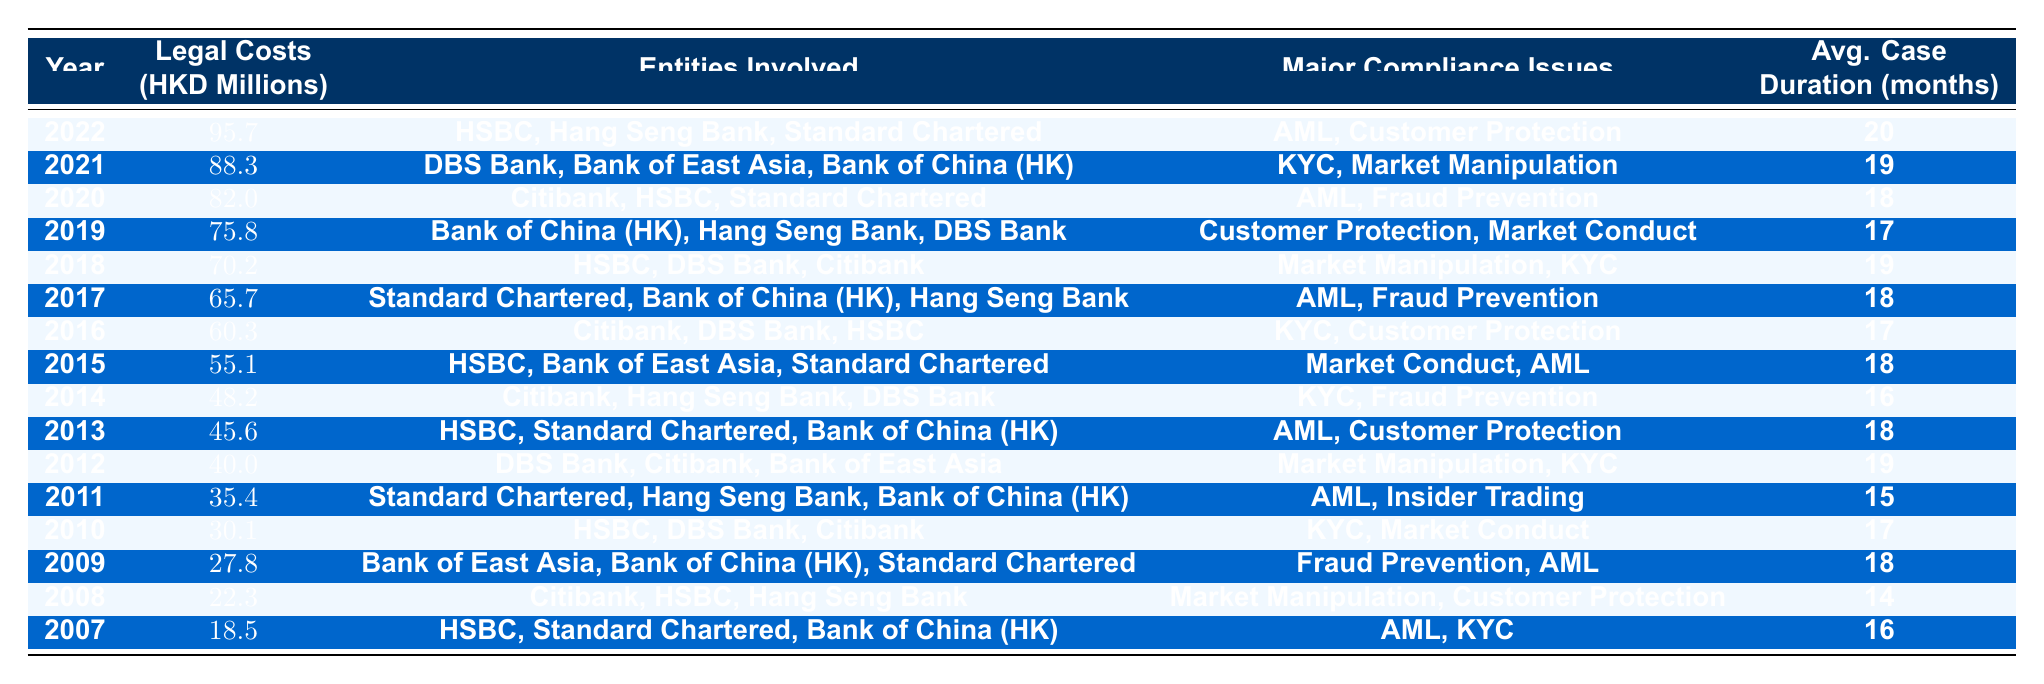What were the legal costs in 2010? The table indicates that the legal costs for the year 2010 were 30.1 million HKD.
Answer: 30.1 million HKD Which year had the highest legal costs and how much was it? By reviewing the table, the year with the highest legal costs is 2022, which were 95.7 million HKD.
Answer: 2022, 95.7 million HKD How many months on average did cases take from 2011 to 2014? To find the average, we sum the average durations for 2011 (15), 2012 (19), 2013 (18), and 2014 (16) which equals 68 months. Dividing by 4 gives us an average of 17 months.
Answer: 17 months Did any year have legal costs exceeding 50 million HKD? Yes, by examining the table, the legal costs exceeded 50 million HKD in the years 2015 (55.1), 2016 (60.3), 2017 (65.7), 2018 (70.2), 2019 (75.8), 2020 (82.0), 2021 (88.3), and 2022 (95.7).
Answer: Yes Which compliance issue was most frequently noted throughout the years? By inspecting the compliance issues listed, AML (Anti-Money Laundering) appears in many years (2007, 2009, 2011, 2013, 2015, 2016, 2017, 2020, 2022). Hence, it is the most frequent issue.
Answer: AML (Anti-Money Laundering) What was the total legal cost from 2007 to 2010? Summing the legal costs from 2007 (18.5), 2008 (22.3), 2009 (27.8), and 2010 (30.1) gives us 98.7 million HKD (18.5 + 22.3 + 27.8 + 30.1).
Answer: 98.7 million HKD Is it true that Hang Seng Bank was involved in compliance issues every year? No, upon checking, Hang Seng Bank was not involved in every year. For example, it was not involved in 2009 and 2010.
Answer: No What is the trend in legal costs from 2007 to 2022? Observing the table, legal costs indicate a steady increase each year from 18.5 million HKD in 2007 to 95.7 million HKD in 2022, showcasing a clear upward trend in legal costs related to compliance issues.
Answer: Increasing trend 